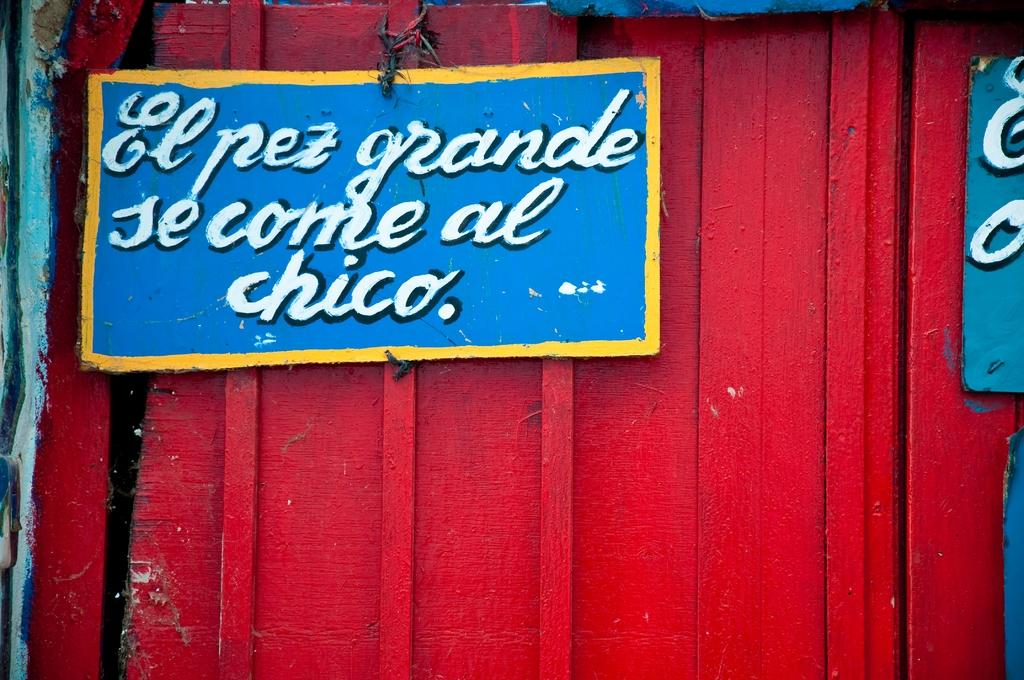What type of door is shown in the image? There is a wooden door in the image. What color is the door? The door is painted red. What other objects are visible in the image? There are boards in the image. What color are the boards? The boards are blue. What can be seen written on the boards? There are words written on the boards in white color. How many mint plants can be seen growing near the door in the image? There are no mint plants visible in the image. Can you tell me the name of the friend who helped paint the door? The image does not provide any information about who helped paint the door or if a friend was involved. 